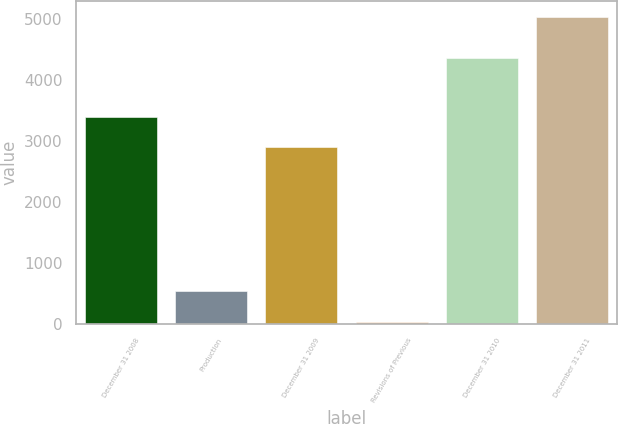<chart> <loc_0><loc_0><loc_500><loc_500><bar_chart><fcel>December 31 2008<fcel>Production<fcel>December 31 2009<fcel>Revisions of Previous<fcel>December 31 2010<fcel>December 31 2011<nl><fcel>3404.5<fcel>538.5<fcel>2904<fcel>38<fcel>4361<fcel>5043<nl></chart> 